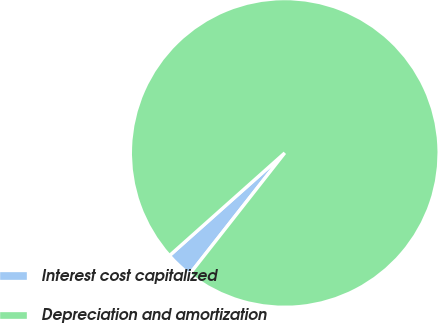<chart> <loc_0><loc_0><loc_500><loc_500><pie_chart><fcel>Interest cost capitalized<fcel>Depreciation and amortization<nl><fcel>2.83%<fcel>97.17%<nl></chart> 